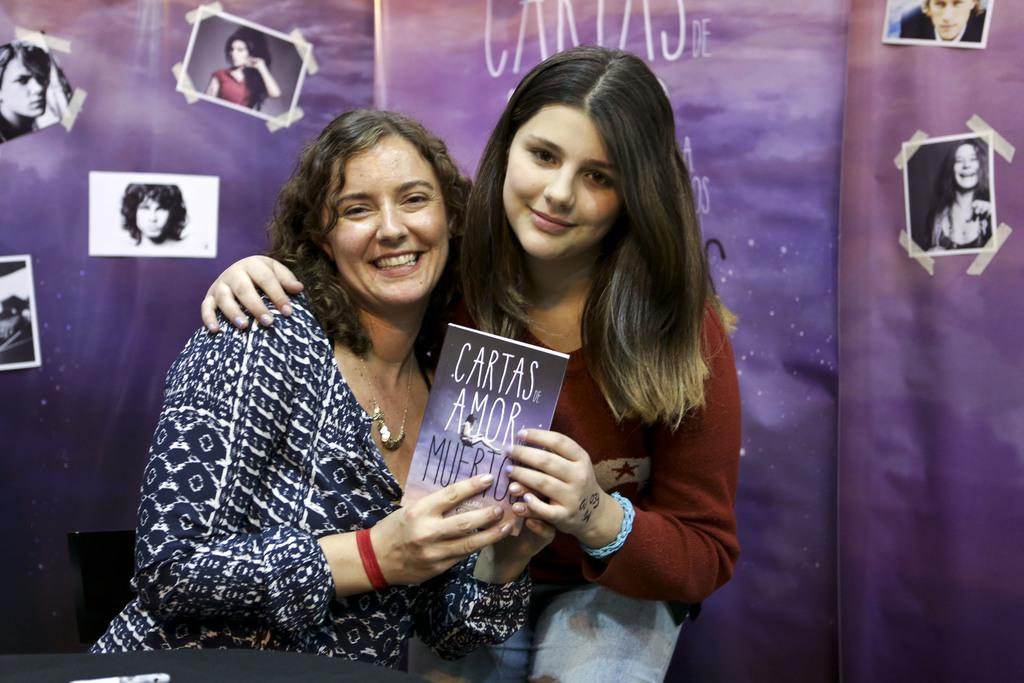How many women are in the image? There are two women in the image. What are the women doing in the image? One woman is sitting on a chair, and the other woman is bending. What are the women holding in the image? Both women are holding a book. What can be seen in the background of the image? There is a wall in the background of the image, and there are photos on the wall. What type of soup is being served in the image? There is no soup present in the image. What time of day is it in the image, considering the women's activities? The time of day cannot be determined from the women's activities in the image. 